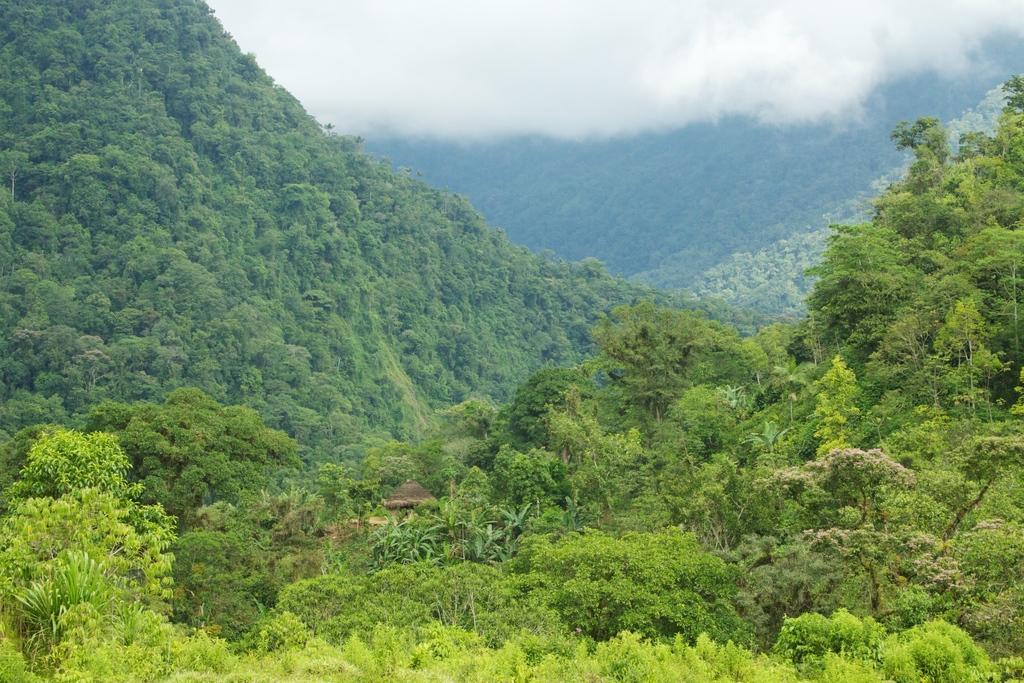How would you summarize this image in a sentence or two? In the center of the image there is a hut. There are trees, mountains and sky. 